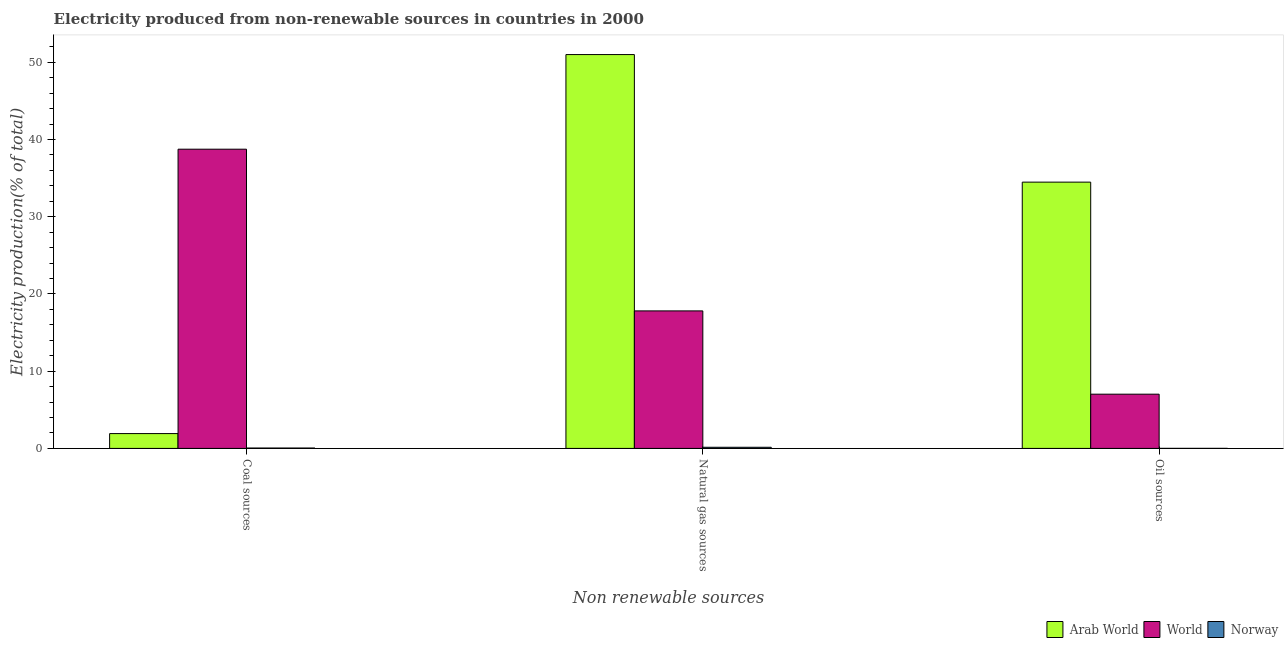How many groups of bars are there?
Your response must be concise. 3. What is the label of the 3rd group of bars from the left?
Give a very brief answer. Oil sources. What is the percentage of electricity produced by natural gas in Norway?
Make the answer very short. 0.15. Across all countries, what is the maximum percentage of electricity produced by natural gas?
Your answer should be compact. 51. Across all countries, what is the minimum percentage of electricity produced by coal?
Keep it short and to the point. 0.05. In which country was the percentage of electricity produced by oil sources maximum?
Provide a succinct answer. Arab World. In which country was the percentage of electricity produced by coal minimum?
Give a very brief answer. Norway. What is the total percentage of electricity produced by natural gas in the graph?
Your response must be concise. 68.95. What is the difference between the percentage of electricity produced by natural gas in Arab World and that in Norway?
Make the answer very short. 50.85. What is the difference between the percentage of electricity produced by oil sources in Arab World and the percentage of electricity produced by natural gas in World?
Provide a succinct answer. 16.68. What is the average percentage of electricity produced by oil sources per country?
Provide a succinct answer. 13.84. What is the difference between the percentage of electricity produced by natural gas and percentage of electricity produced by oil sources in Arab World?
Offer a very short reply. 16.52. In how many countries, is the percentage of electricity produced by coal greater than 12 %?
Your answer should be compact. 1. What is the ratio of the percentage of electricity produced by natural gas in Norway to that in Arab World?
Your answer should be very brief. 0. Is the difference between the percentage of electricity produced by coal in Norway and World greater than the difference between the percentage of electricity produced by oil sources in Norway and World?
Ensure brevity in your answer.  No. What is the difference between the highest and the second highest percentage of electricity produced by oil sources?
Keep it short and to the point. 27.46. What is the difference between the highest and the lowest percentage of electricity produced by oil sources?
Offer a terse response. 34.48. Is the sum of the percentage of electricity produced by oil sources in Norway and Arab World greater than the maximum percentage of electricity produced by coal across all countries?
Offer a terse response. No. What does the 3rd bar from the left in Coal sources represents?
Your response must be concise. Norway. What does the 1st bar from the right in Natural gas sources represents?
Make the answer very short. Norway. How many bars are there?
Ensure brevity in your answer.  9. What is the difference between two consecutive major ticks on the Y-axis?
Your answer should be very brief. 10. Are the values on the major ticks of Y-axis written in scientific E-notation?
Your answer should be very brief. No. Does the graph contain grids?
Your answer should be compact. No. How are the legend labels stacked?
Make the answer very short. Horizontal. What is the title of the graph?
Provide a succinct answer. Electricity produced from non-renewable sources in countries in 2000. Does "Guinea-Bissau" appear as one of the legend labels in the graph?
Provide a succinct answer. No. What is the label or title of the X-axis?
Ensure brevity in your answer.  Non renewable sources. What is the Electricity production(% of total) in Arab World in Coal sources?
Your response must be concise. 1.92. What is the Electricity production(% of total) in World in Coal sources?
Offer a terse response. 38.75. What is the Electricity production(% of total) of Norway in Coal sources?
Offer a terse response. 0.05. What is the Electricity production(% of total) in Arab World in Natural gas sources?
Make the answer very short. 51. What is the Electricity production(% of total) in World in Natural gas sources?
Your answer should be very brief. 17.81. What is the Electricity production(% of total) in Norway in Natural gas sources?
Your answer should be compact. 0.15. What is the Electricity production(% of total) of Arab World in Oil sources?
Make the answer very short. 34.48. What is the Electricity production(% of total) of World in Oil sources?
Make the answer very short. 7.02. What is the Electricity production(% of total) in Norway in Oil sources?
Provide a short and direct response. 0.01. Across all Non renewable sources, what is the maximum Electricity production(% of total) in Arab World?
Your answer should be compact. 51. Across all Non renewable sources, what is the maximum Electricity production(% of total) of World?
Make the answer very short. 38.75. Across all Non renewable sources, what is the maximum Electricity production(% of total) of Norway?
Provide a succinct answer. 0.15. Across all Non renewable sources, what is the minimum Electricity production(% of total) of Arab World?
Provide a succinct answer. 1.92. Across all Non renewable sources, what is the minimum Electricity production(% of total) in World?
Offer a very short reply. 7.02. Across all Non renewable sources, what is the minimum Electricity production(% of total) in Norway?
Provide a short and direct response. 0.01. What is the total Electricity production(% of total) in Arab World in the graph?
Ensure brevity in your answer.  87.4. What is the total Electricity production(% of total) of World in the graph?
Provide a short and direct response. 63.58. What is the total Electricity production(% of total) of Norway in the graph?
Your answer should be compact. 0.2. What is the difference between the Electricity production(% of total) of Arab World in Coal sources and that in Natural gas sources?
Give a very brief answer. -49.08. What is the difference between the Electricity production(% of total) in World in Coal sources and that in Natural gas sources?
Give a very brief answer. 20.94. What is the difference between the Electricity production(% of total) of Norway in Coal sources and that in Natural gas sources?
Provide a short and direct response. -0.1. What is the difference between the Electricity production(% of total) of Arab World in Coal sources and that in Oil sources?
Offer a terse response. -32.56. What is the difference between the Electricity production(% of total) in World in Coal sources and that in Oil sources?
Your answer should be very brief. 31.72. What is the difference between the Electricity production(% of total) in Norway in Coal sources and that in Oil sources?
Make the answer very short. 0.04. What is the difference between the Electricity production(% of total) of Arab World in Natural gas sources and that in Oil sources?
Keep it short and to the point. 16.52. What is the difference between the Electricity production(% of total) of World in Natural gas sources and that in Oil sources?
Ensure brevity in your answer.  10.78. What is the difference between the Electricity production(% of total) in Norway in Natural gas sources and that in Oil sources?
Offer a very short reply. 0.14. What is the difference between the Electricity production(% of total) in Arab World in Coal sources and the Electricity production(% of total) in World in Natural gas sources?
Make the answer very short. -15.89. What is the difference between the Electricity production(% of total) of Arab World in Coal sources and the Electricity production(% of total) of Norway in Natural gas sources?
Offer a very short reply. 1.77. What is the difference between the Electricity production(% of total) of World in Coal sources and the Electricity production(% of total) of Norway in Natural gas sources?
Keep it short and to the point. 38.6. What is the difference between the Electricity production(% of total) of Arab World in Coal sources and the Electricity production(% of total) of World in Oil sources?
Offer a terse response. -5.1. What is the difference between the Electricity production(% of total) of Arab World in Coal sources and the Electricity production(% of total) of Norway in Oil sources?
Give a very brief answer. 1.91. What is the difference between the Electricity production(% of total) in World in Coal sources and the Electricity production(% of total) in Norway in Oil sources?
Your answer should be very brief. 38.74. What is the difference between the Electricity production(% of total) of Arab World in Natural gas sources and the Electricity production(% of total) of World in Oil sources?
Offer a terse response. 43.98. What is the difference between the Electricity production(% of total) in Arab World in Natural gas sources and the Electricity production(% of total) in Norway in Oil sources?
Ensure brevity in your answer.  50.99. What is the difference between the Electricity production(% of total) of World in Natural gas sources and the Electricity production(% of total) of Norway in Oil sources?
Provide a succinct answer. 17.8. What is the average Electricity production(% of total) in Arab World per Non renewable sources?
Keep it short and to the point. 29.13. What is the average Electricity production(% of total) in World per Non renewable sources?
Your response must be concise. 21.19. What is the average Electricity production(% of total) in Norway per Non renewable sources?
Make the answer very short. 0.07. What is the difference between the Electricity production(% of total) of Arab World and Electricity production(% of total) of World in Coal sources?
Your answer should be very brief. -36.83. What is the difference between the Electricity production(% of total) in Arab World and Electricity production(% of total) in Norway in Coal sources?
Offer a very short reply. 1.87. What is the difference between the Electricity production(% of total) of World and Electricity production(% of total) of Norway in Coal sources?
Offer a very short reply. 38.7. What is the difference between the Electricity production(% of total) in Arab World and Electricity production(% of total) in World in Natural gas sources?
Your answer should be compact. 33.19. What is the difference between the Electricity production(% of total) of Arab World and Electricity production(% of total) of Norway in Natural gas sources?
Ensure brevity in your answer.  50.85. What is the difference between the Electricity production(% of total) of World and Electricity production(% of total) of Norway in Natural gas sources?
Your answer should be very brief. 17.66. What is the difference between the Electricity production(% of total) in Arab World and Electricity production(% of total) in World in Oil sources?
Give a very brief answer. 27.46. What is the difference between the Electricity production(% of total) of Arab World and Electricity production(% of total) of Norway in Oil sources?
Your answer should be compact. 34.48. What is the difference between the Electricity production(% of total) of World and Electricity production(% of total) of Norway in Oil sources?
Make the answer very short. 7.02. What is the ratio of the Electricity production(% of total) of Arab World in Coal sources to that in Natural gas sources?
Ensure brevity in your answer.  0.04. What is the ratio of the Electricity production(% of total) in World in Coal sources to that in Natural gas sources?
Ensure brevity in your answer.  2.18. What is the ratio of the Electricity production(% of total) in Norway in Coal sources to that in Natural gas sources?
Provide a short and direct response. 0.34. What is the ratio of the Electricity production(% of total) in Arab World in Coal sources to that in Oil sources?
Your answer should be very brief. 0.06. What is the ratio of the Electricity production(% of total) in World in Coal sources to that in Oil sources?
Your response must be concise. 5.52. What is the ratio of the Electricity production(% of total) of Arab World in Natural gas sources to that in Oil sources?
Your response must be concise. 1.48. What is the ratio of the Electricity production(% of total) in World in Natural gas sources to that in Oil sources?
Keep it short and to the point. 2.54. What is the ratio of the Electricity production(% of total) in Norway in Natural gas sources to that in Oil sources?
Your answer should be very brief. 23.44. What is the difference between the highest and the second highest Electricity production(% of total) of Arab World?
Ensure brevity in your answer.  16.52. What is the difference between the highest and the second highest Electricity production(% of total) in World?
Offer a very short reply. 20.94. What is the difference between the highest and the second highest Electricity production(% of total) of Norway?
Offer a terse response. 0.1. What is the difference between the highest and the lowest Electricity production(% of total) of Arab World?
Provide a short and direct response. 49.08. What is the difference between the highest and the lowest Electricity production(% of total) of World?
Give a very brief answer. 31.72. What is the difference between the highest and the lowest Electricity production(% of total) of Norway?
Keep it short and to the point. 0.14. 